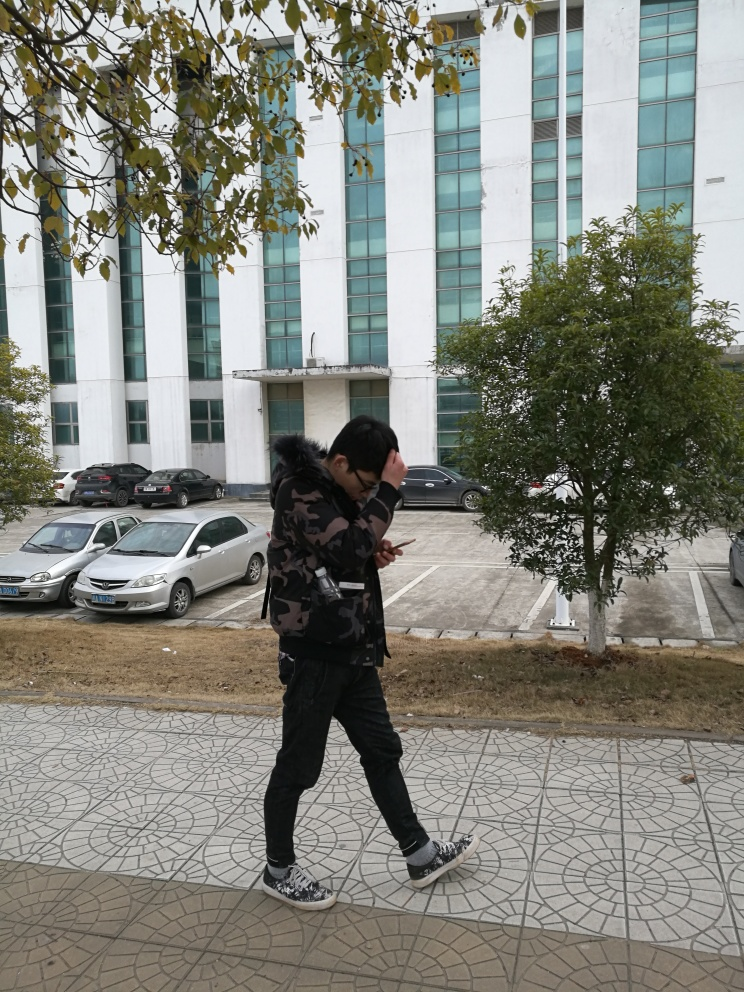Overall, how would you rate the image quality?
A. poor
B. good
C. average
Answer with the option's letter from the given choices directly.
 B. 